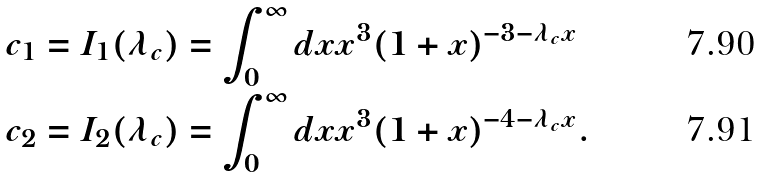Convert formula to latex. <formula><loc_0><loc_0><loc_500><loc_500>c _ { 1 } = I _ { 1 } ( \lambda _ { c } ) & = \int ^ { \infty } _ { 0 } d x x ^ { 3 } ( 1 + x ) ^ { - 3 - \lambda _ { c } x } \\ c _ { 2 } = I _ { 2 } ( \lambda _ { c } ) & = \int ^ { \infty } _ { 0 } d x x ^ { 3 } ( 1 + x ) ^ { - 4 - \lambda _ { c } x } .</formula> 